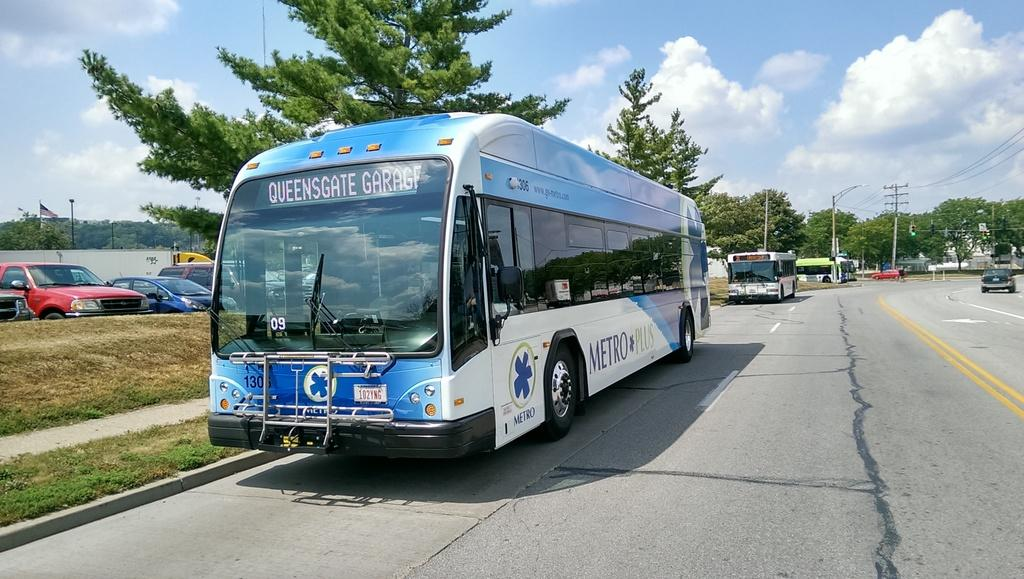<image>
Give a short and clear explanation of the subsequent image. a metro plus bus heading to queensgate garage 